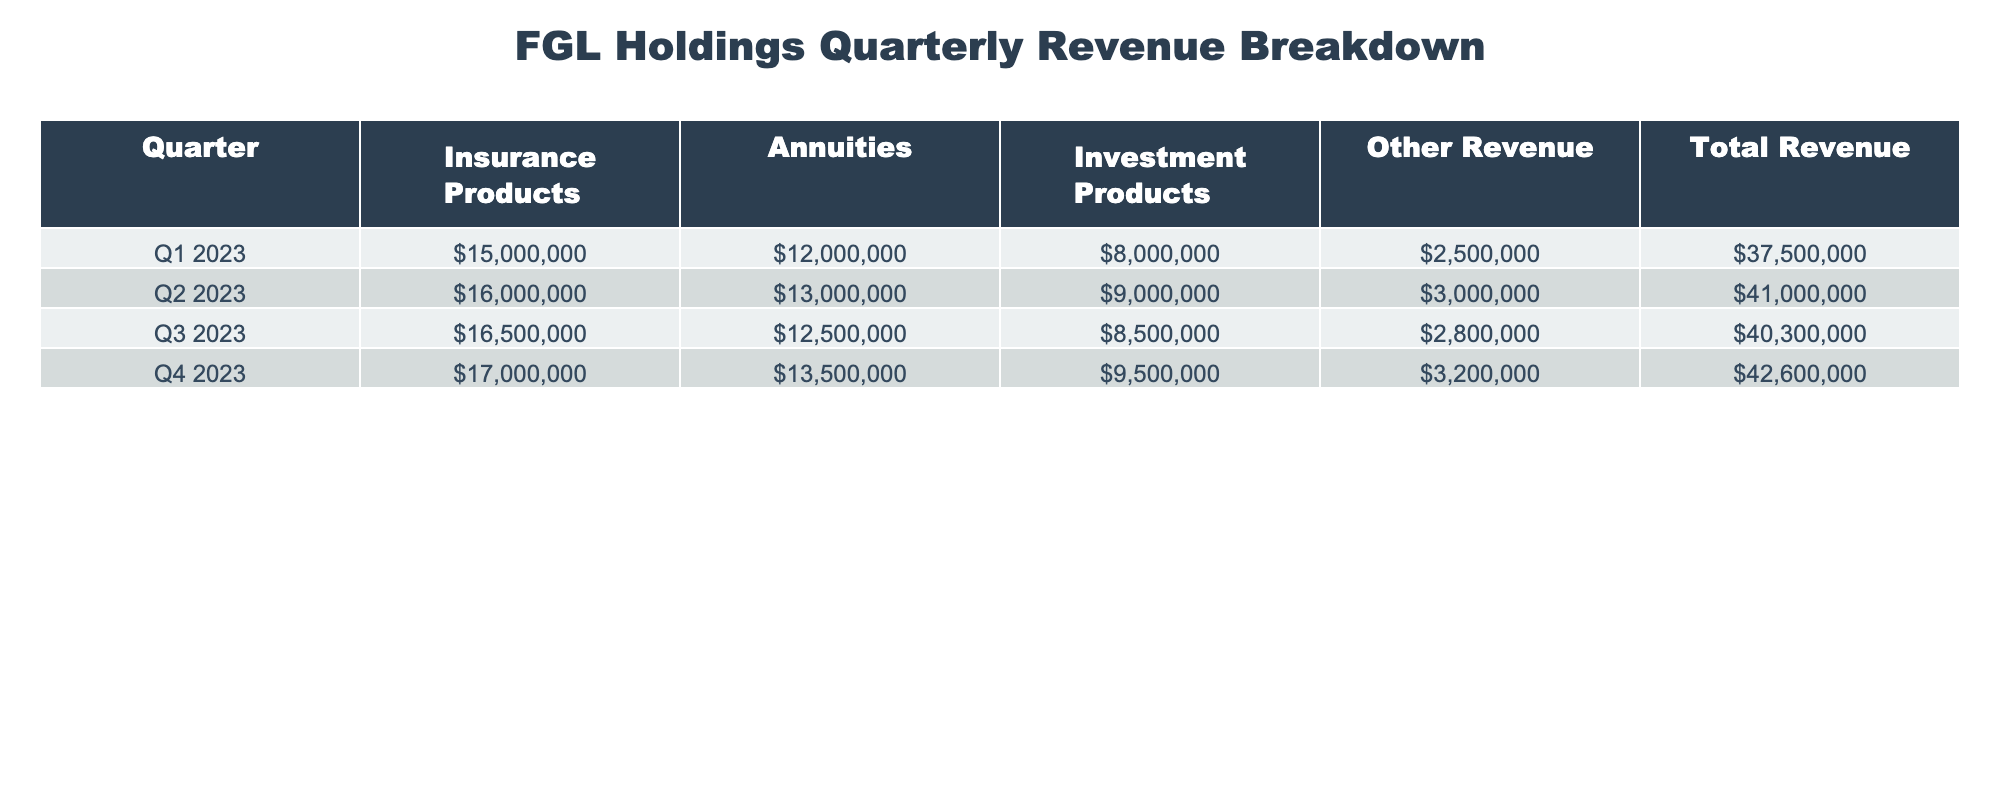What was the total revenue for Q3 2023? The table shows that the total revenue for Q3 2023 is listed in the Total Revenue column, which states 40,300,000.
Answer: 40,300,000 Which product line had the highest revenue in Q4 2023? In Q4 2023, the Insurance Products category had the highest value in the respective column, with a revenue amount of 17,000,000.
Answer: Insurance Products What is the average revenue from Annuities across all four quarters? The revenues from Annuities for each quarter are 12,000,000, 13,000,000, 12,500,000, and 13,500,000. Adding these gives a total of 51,000,000, then dividing by four results in an average of 12,750,000.
Answer: 12,750,000 Did the total revenue increase from Q1 2023 to Q4 2023? By examining the Total Revenue column, Q1 2023 shows 37,500,000 and Q4 2023 shows 42,600,000. This indicates an increase of 5,100,000 from Q1 to Q4.
Answer: Yes What is the difference in revenue from Other Revenue between Q2 2023 and Q3 2023? The Other Revenue values are 3,000,000 for Q2 2023 and 2,800,000 for Q3 2023. The difference is found by subtracting 2,800,000 from 3,000,000, resulting in a difference of 200,000.
Answer: 200,000 What is the total revenue for the year from Investment Products? Adding the Investment Products revenue for all quarters gives: 8,000,000 + 9,000,000 + 8,500,000 + 9,500,000 = 35,000,000 for the year.
Answer: 35,000,000 Was the revenue from Insurance Products in Q3 2023 lower than in Q2 2023? The Insurance Products revenue in Q3 2023 is 16,500,000 while in Q2 2023 it is 16,000,000. 16,500,000 is greater than 16,000,000; therefore, it was not lower.
Answer: No How much did total revenue increase from Q1 2023 to Q2 2023? The total revenue in Q1 2023 is 37,500,000 and in Q2 2023 is 41,000,000. The increase is calculated by subtracting Q1 from Q2: 41,000,000 - 37,500,000 = 3,500,000.
Answer: 3,500,000 Which quarter had the lowest revenue from Other Revenue? The table shows Other Revenue for each quarter as 2,500,000, 3,000,000, 2,800,000, and 3,200,000. The lowest value is seen in Q1 2023 at 2,500,000.
Answer: Q1 2023 